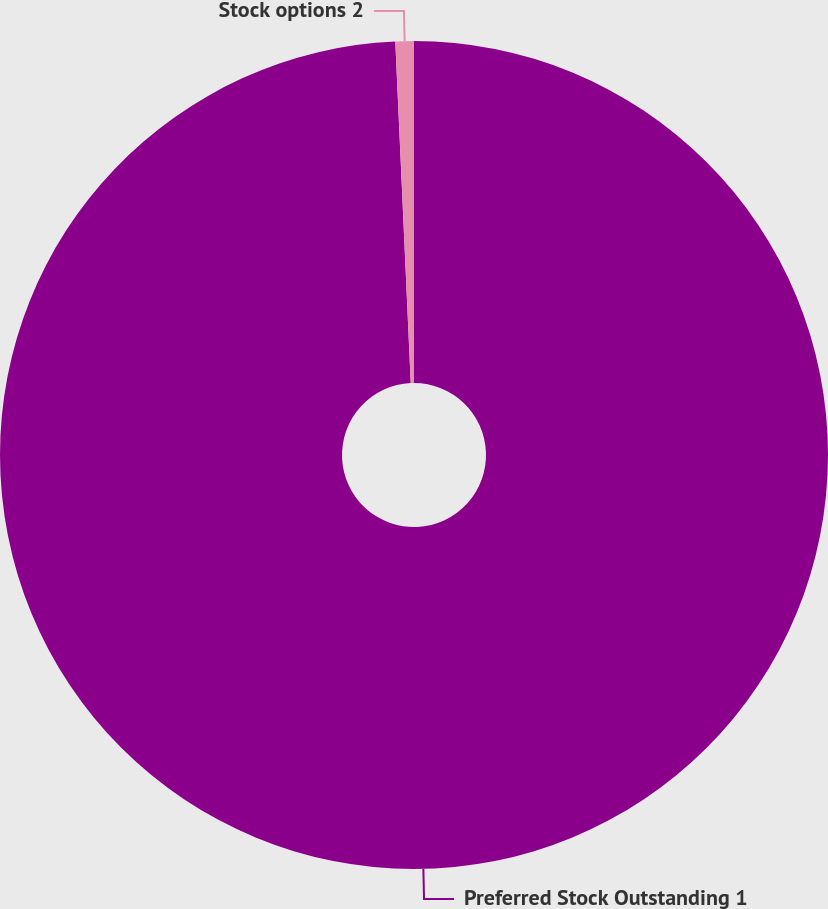<chart> <loc_0><loc_0><loc_500><loc_500><pie_chart><fcel>Preferred Stock Outstanding 1<fcel>Stock options 2<nl><fcel>99.28%<fcel>0.72%<nl></chart> 